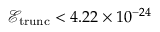<formula> <loc_0><loc_0><loc_500><loc_500>\mathcal { E } _ { t r u n c } < 4 . 2 2 \times 1 0 ^ { - 2 4 }</formula> 